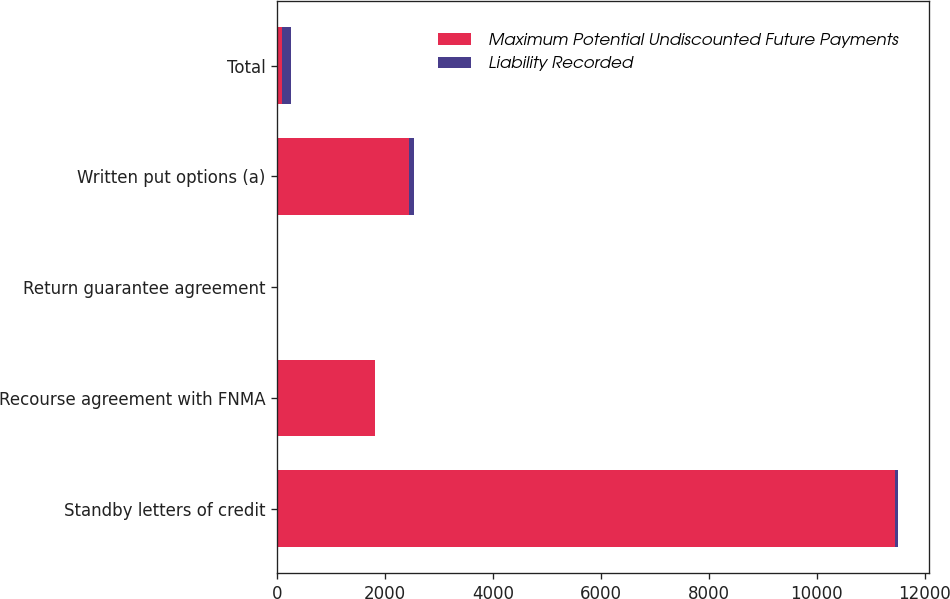<chart> <loc_0><loc_0><loc_500><loc_500><stacked_bar_chart><ecel><fcel>Standby letters of credit<fcel>Recourse agreement with FNMA<fcel>Return guarantee agreement<fcel>Written put options (a)<fcel>Total<nl><fcel>Maximum Potential Undiscounted Future Payments<fcel>11447<fcel>1813<fcel>4<fcel>2439<fcel>98<nl><fcel>Liability Recorded<fcel>62<fcel>4<fcel>4<fcel>98<fcel>168<nl></chart> 